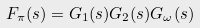<formula> <loc_0><loc_0><loc_500><loc_500>F _ { \pi } ( s ) = G _ { 1 } ( s ) G _ { 2 } ( s ) G _ { \omega } ( s )</formula> 